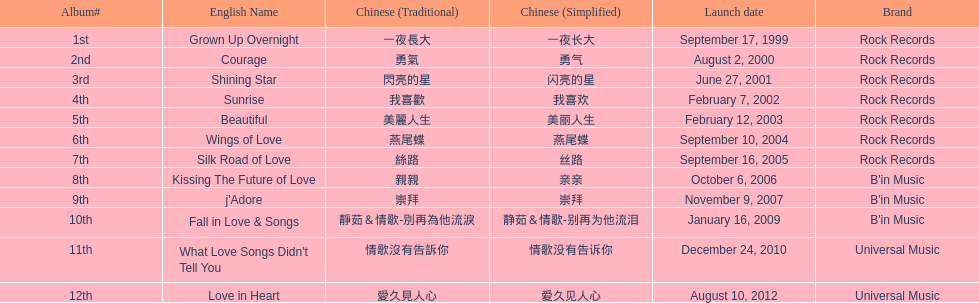Which album was released later, beautiful, or j'adore? J'adore. 